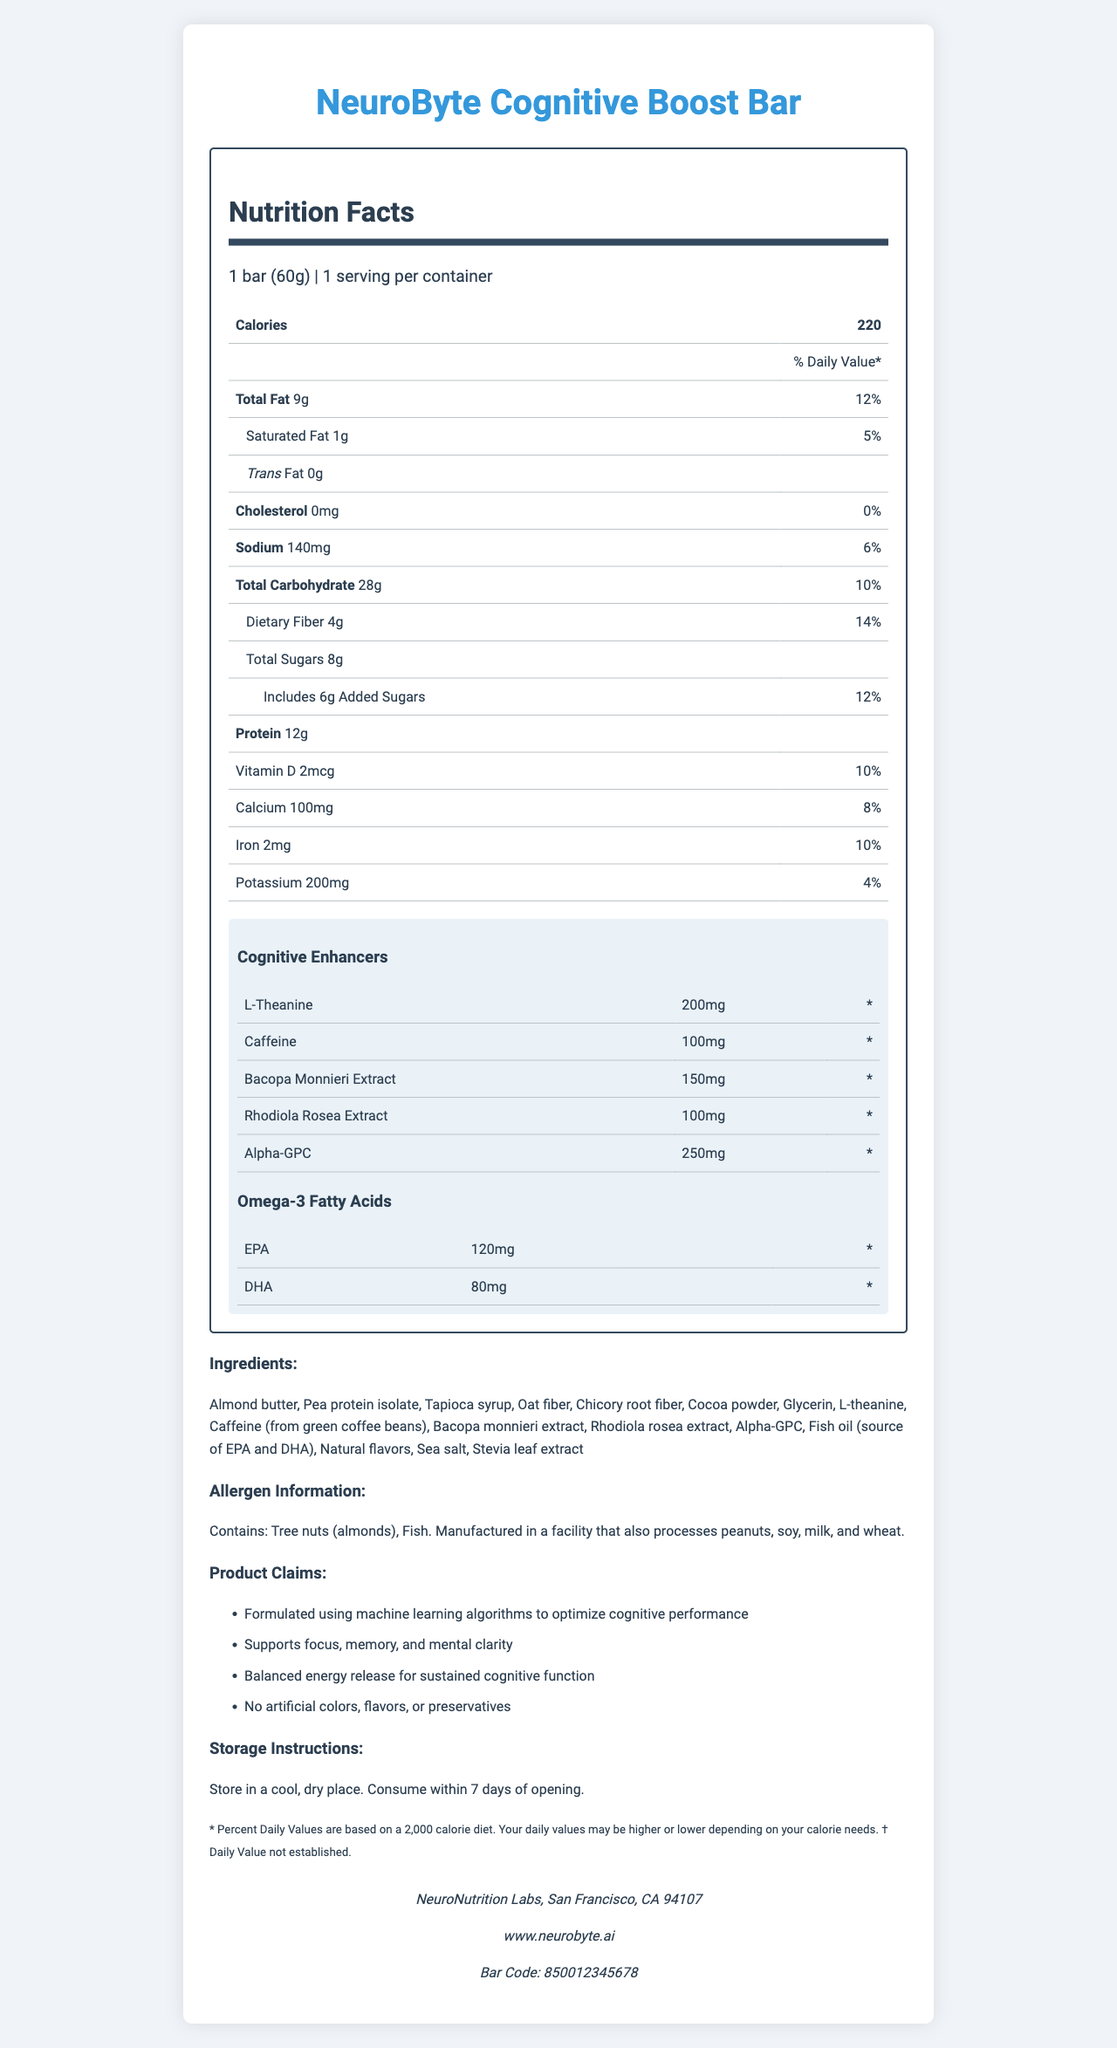what is the total fat content per serving? The nutrition label indicates the total fat content of 9g per serving.
Answer: 9g how many milligrams of sodium are in one serving? The nutrition label specifies that there are 140mg of sodium per serving.
Answer: 140mg how much protein does the NeuroByte Cognitive Boost Bar provide? The document lists 12g of protein in one bar.
Answer: 12g what is the daily value percentage for dietary fiber? The nutrition label shows that the daily value percentage for dietary fiber is 14%.
Answer: 14% what are the main cognitive enhancers in this bar? The section under "Cognitive Enhancers" lists these five substances.
Answer: L-Theanine, Caffeine, Bacopa Monnieri Extract, Rhodiola Rosea Extract, Alpha-GPC which ingredient is not commonly associated with cognitive enhancement? A. L-Theanine B. Caffeine C. Oat fiber D. Alpha-GPC E. Rhodiola Rosea Extract Oat fiber is not typically known for cognitive enhancement, whereas the others are.
Answer: C. Oat fiber how much vitamin D does one bar contain? The nutrition facts state that one bar contains 2mcg of vitamin D.
Answer: 2mcg does the NeuroByte Cognitive Boost Bar contain trans fat? The nutrition label shows 0g of trans fat.
Answer: No which of the following best describes the storage instructions for the bar? A. Store in a refrigerator B. Store in a cool, dry place C. Store in a humid environment D. Store in a warm place The storage section mentions that the bar should be stored in a cool, dry place.
Answer: B. Store in a cool, dry place what is the total carbohydrate content per serving? The nutrition label lists the total carbohydrate content as 28g per serving.
Answer: 28g are there any artificial colors, flavors, or preservatives in this product? The product claims section states that there are no artificial colors, flavors, or preservatives.
Answer: No summarize the main idea of the document. The document provides comprehensive details about the nutritional values, ingredients, cognitive benefits, and other relevant information for the NeuroByte Cognitive Boost Bar.
Answer: The document is a nutrition facts label for the NeuroByte Cognitive Boost Bar, highlighting serving size, nutritional content, ingredients, allergen information, cognitive enhancers, storage instructions, and product claims. does the bar provide any omega-3 fatty acids? The document includes a section on Omega-3 fatty acids, listing EPA and DHA content.
Answer: Yes what is the source of caffeine in this bar? The ingredient list specifies that caffeine is sourced from green coffee beans.
Answer: Green coffee beans what is the total sugar content in the bar, including added sugars? The nutrition label shows 8g total sugars with 6g coming from added sugars.
Answer: 8g total sugars, includes 6g added sugars how much calcium is present in one bar? The nutrition label indicates that one bar contains 100mg of calcium.
Answer: 100mg where is the NeuroByte Cognitive Boost Bar manufactured? The manufacturer information at the bottom of the document states it is made by NeuroNutrition Labs in San Francisco, CA.
Answer: San Francisco, CA 94107 what are the allergen warnings for this product? The allergen information section lists specific allergens and mentions the manufacturing facility processes other allergens.
Answer: Contains: Tree nuts (almonds), Fish. Manufactured in a facility that also processes peanuts, soy, milk, and wheat. how many servings are in one container? The serving information section indicates that there is 1 serving per container.
Answer: 1 how many total bars are sold yearly? The nutrition label does not provide information regarding the sales volume of the product.
Answer: Cannot be determined 